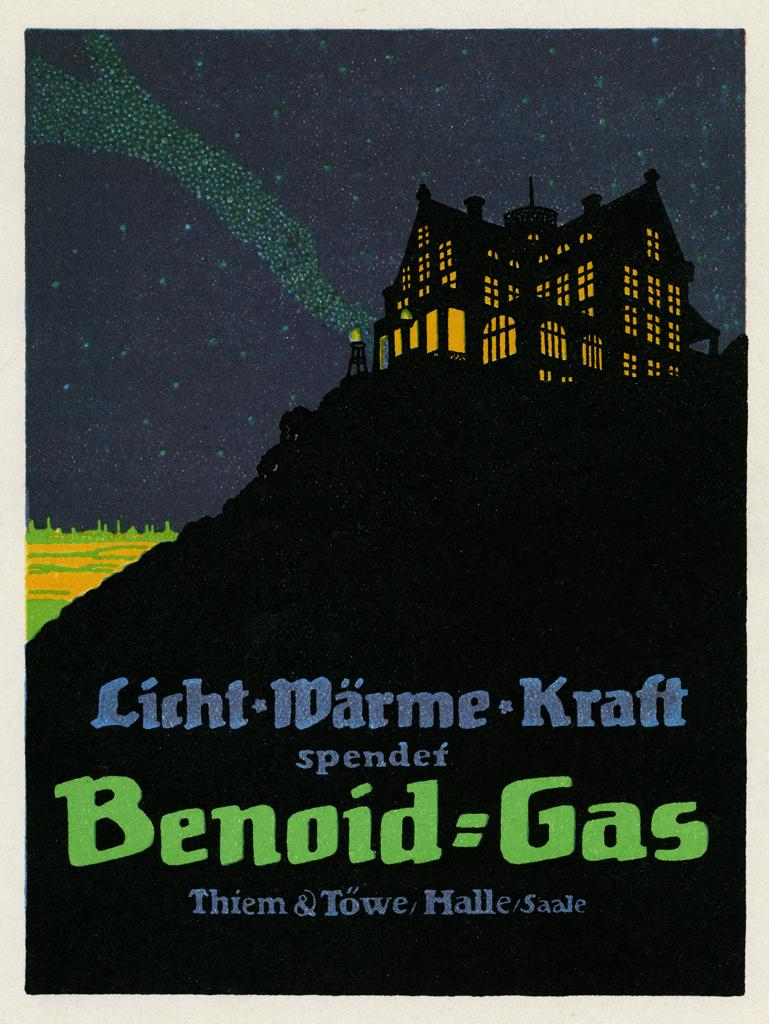<image>
Render a clear and concise summary of the photo. A poster for some work by Benoid Gas shows a house lit up at night. 